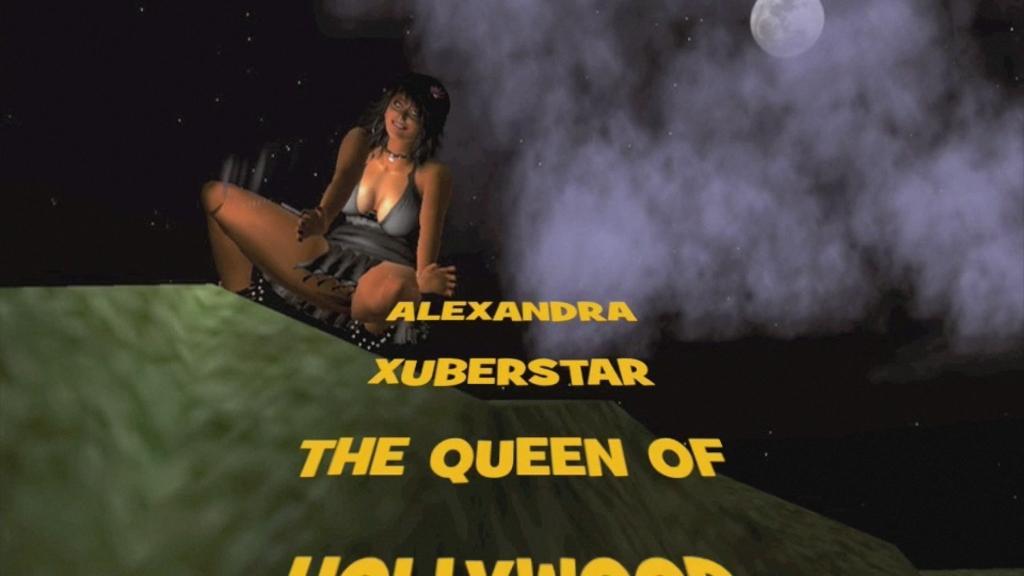Describe this image in one or two sentences. This is an animated image and here we can see a lady sitting and at the top, we can see a moon in the sky. At the bottom, we can see some text written. 